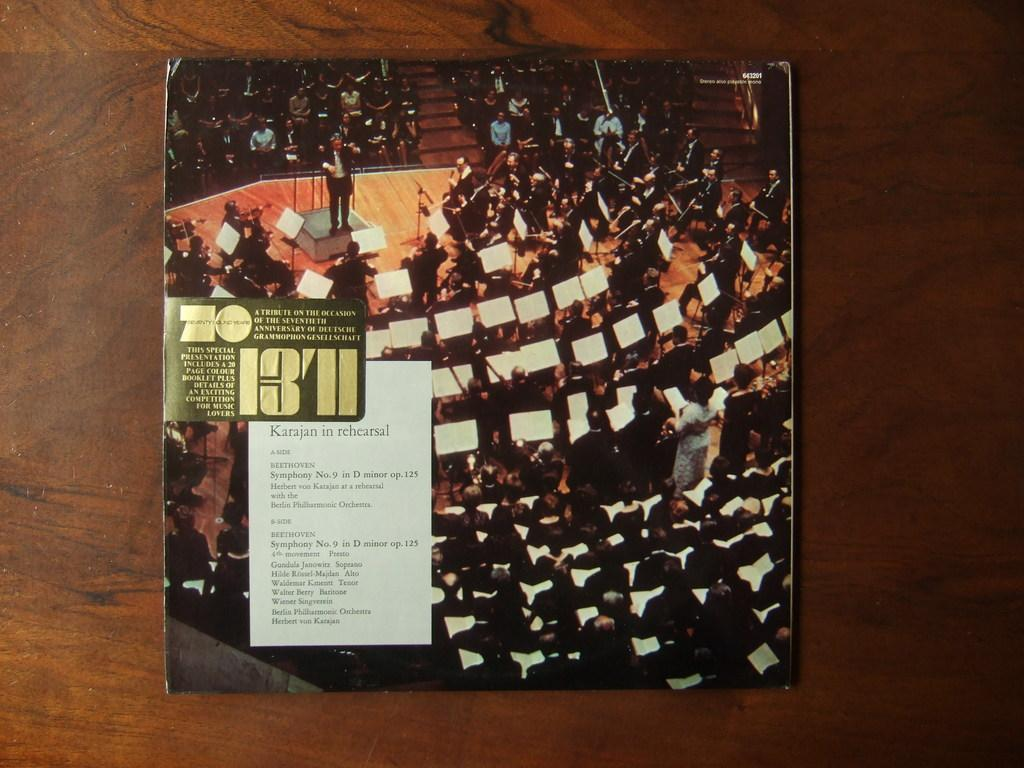<image>
Give a short and clear explanation of the subsequent image. A picture of a crowd of people holding white papers and the number 1371 on a green sign. 